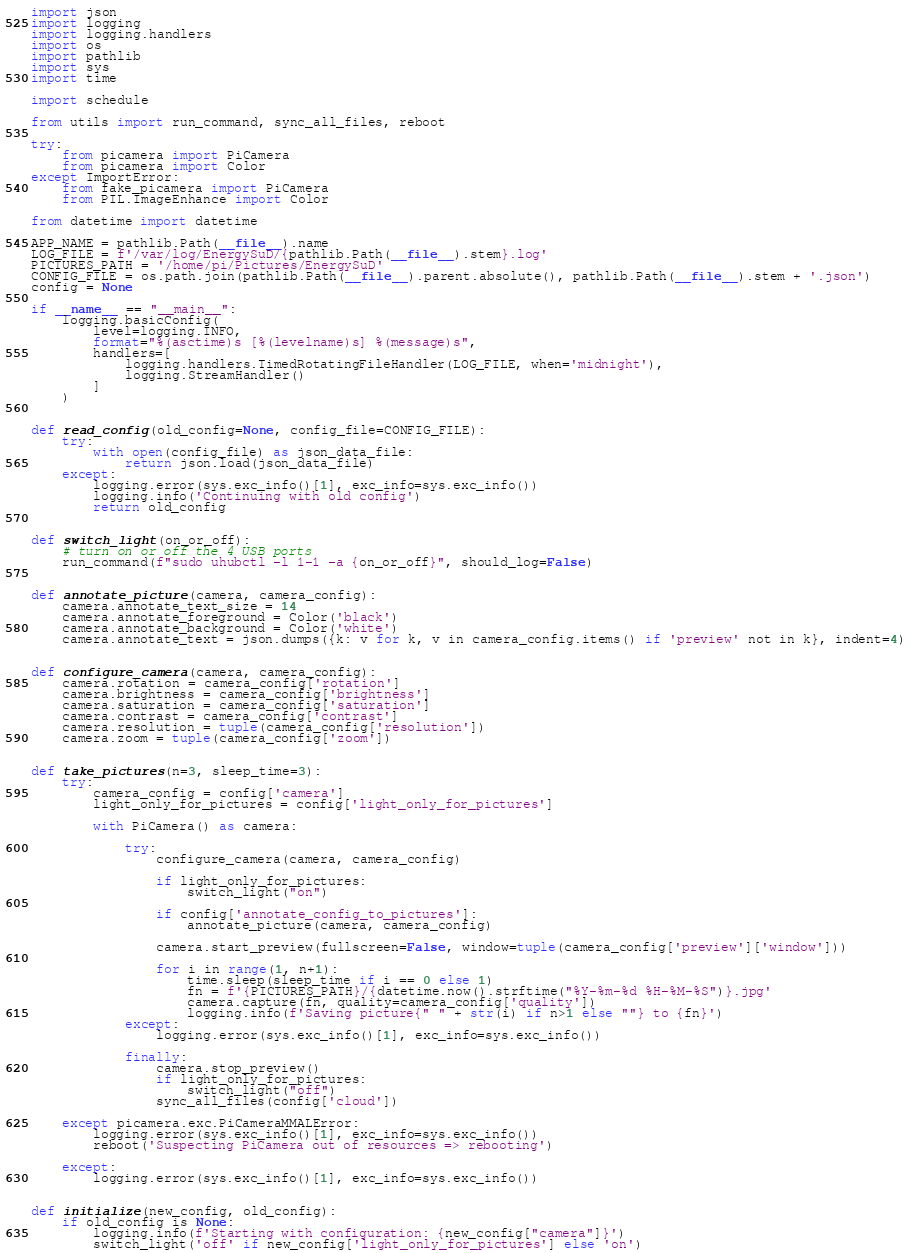Convert code to text. <code><loc_0><loc_0><loc_500><loc_500><_Python_>import json
import logging
import logging.handlers
import os
import pathlib
import sys
import time

import schedule

from utils import run_command, sync_all_files, reboot

try:
    from picamera import PiCamera
    from picamera import Color
except ImportError:
    from fake_picamera import PiCamera
    from PIL.ImageEnhance import Color

from datetime import datetime

APP_NAME = pathlib.Path(__file__).name
LOG_FILE = f'/var/log/EnergySuD/{pathlib.Path(__file__).stem}.log'
PICTURES_PATH = '/home/pi/Pictures/EnergySuD'
CONFIG_FILE = os.path.join(pathlib.Path(__file__).parent.absolute(), pathlib.Path(__file__).stem + '.json')
config = None

if __name__ == "__main__":
    logging.basicConfig(
        level=logging.INFO,
        format="%(asctime)s [%(levelname)s] %(message)s",
        handlers=[
            logging.handlers.TimedRotatingFileHandler(LOG_FILE, when='midnight'),
            logging.StreamHandler()
        ]
    )


def read_config(old_config=None, config_file=CONFIG_FILE):
    try:
        with open(config_file) as json_data_file:
            return json.load(json_data_file)
    except:
        logging.error(sys.exc_info()[1], exc_info=sys.exc_info())
        logging.info('Continuing with old config')
        return old_config


def switch_light(on_or_off):
    # turn on or off the 4 USB ports
    run_command(f"sudo uhubctl -l 1-1 -a {on_or_off}", should_log=False)


def annotate_picture(camera, camera_config):
    camera.annotate_text_size = 14
    camera.annotate_foreground = Color('black')
    camera.annotate_background = Color('white')
    camera.annotate_text = json.dumps({k: v for k, v in camera_config.items() if 'preview' not in k}, indent=4)


def configure_camera(camera, camera_config):
    camera.rotation = camera_config['rotation']
    camera.brightness = camera_config['brightness']
    camera.saturation = camera_config['saturation']
    camera.contrast = camera_config['contrast']
    camera.resolution = tuple(camera_config['resolution'])
    camera.zoom = tuple(camera_config['zoom'])


def take_pictures(n=3, sleep_time=3):
    try:
        camera_config = config['camera']
        light_only_for_pictures = config['light_only_for_pictures']

        with PiCamera() as camera:

            try:
                configure_camera(camera, camera_config)

                if light_only_for_pictures:
                    switch_light("on")

                if config['annotate_config_to_pictures']:
                    annotate_picture(camera, camera_config)

                camera.start_preview(fullscreen=False, window=tuple(camera_config['preview']['window']))

                for i in range(1, n+1):
                    time.sleep(sleep_time if i == 0 else 1)
                    fn = f'{PICTURES_PATH}/{datetime.now().strftime("%Y-%m-%d %H-%M-%S")}.jpg'
                    camera.capture(fn, quality=camera_config['quality'])
                    logging.info(f'Saving picture{" " + str(i) if n>1 else ""} to {fn}')
            except:
                logging.error(sys.exc_info()[1], exc_info=sys.exc_info())

            finally:
                camera.stop_preview()
                if light_only_for_pictures:
                    switch_light("off")
                sync_all_files(config['cloud'])

    except picamera.exc.PiCameraMMALError:
        logging.error(sys.exc_info()[1], exc_info=sys.exc_info())
        reboot('Suspecting PiCamera out of resources => rebooting')

    except:
        logging.error(sys.exc_info()[1], exc_info=sys.exc_info())


def initialize(new_config, old_config):
    if old_config is None:
        logging.info(f'Starting with configuration: {new_config["camera"]}')
        switch_light('off' if new_config['light_only_for_pictures'] else 'on')</code> 